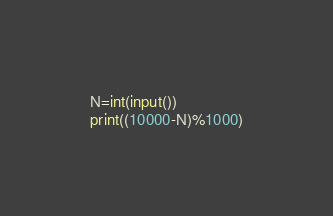<code> <loc_0><loc_0><loc_500><loc_500><_Python_>N=int(input())
print((10000-N)%1000)</code> 